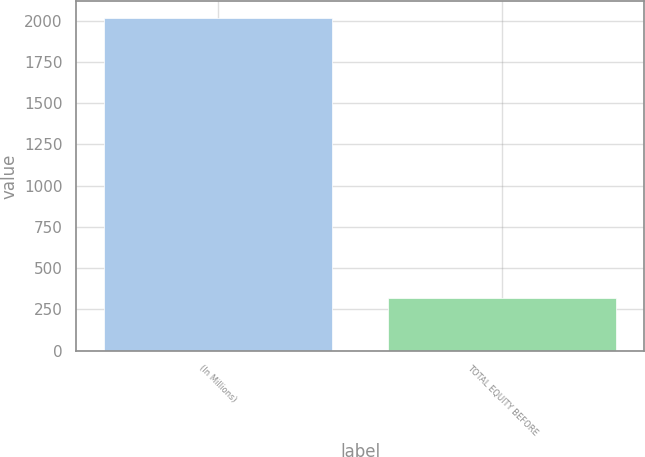<chart> <loc_0><loc_0><loc_500><loc_500><bar_chart><fcel>(In Millions)<fcel>TOTAL EQUITY BEFORE<nl><fcel>2018<fcel>321<nl></chart> 